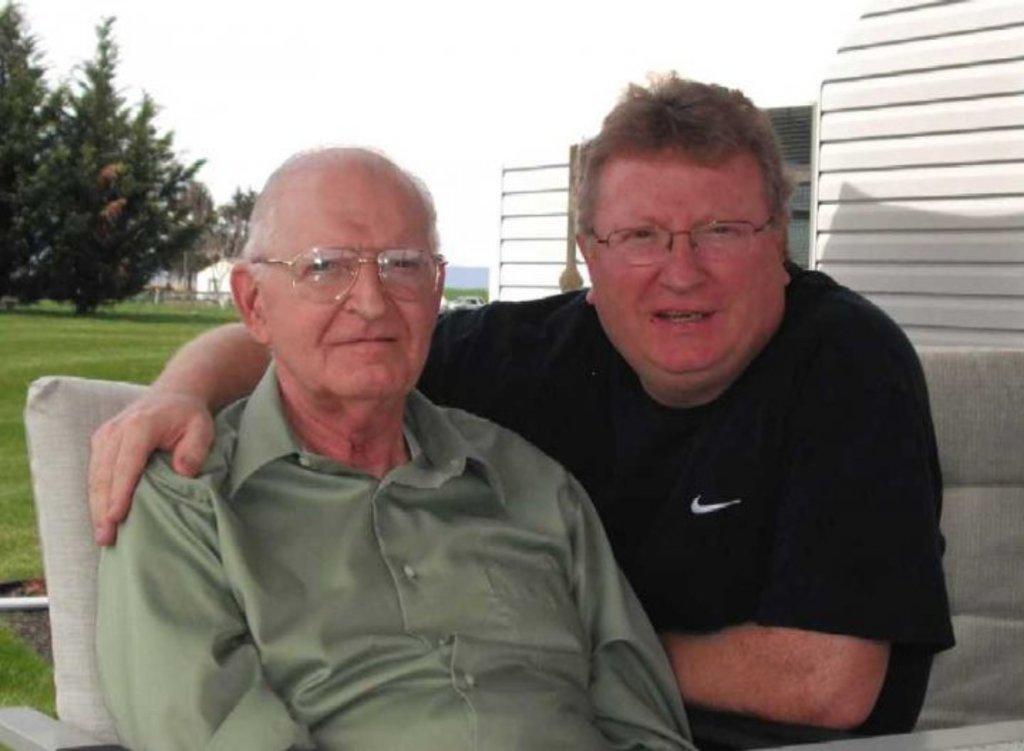How would you summarize this image in a sentence or two? In front of the image there are two people sitting on the chairs. Behind them there are trees, buildings and a car. At the bottom of the image there is grass on the surface. At the top of the image there is sky. 